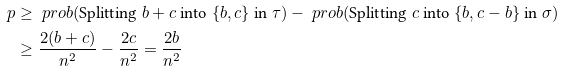<formula> <loc_0><loc_0><loc_500><loc_500>p & \geq \ p r o b ( \text {Splitting $b+c$ into $\{b, c\}$ in $\tau$} ) - \ p r o b ( \text {Splitting $c$ into $\{b, c-b\}$ in $\sigma$} ) \\ & \geq \frac { 2 ( b + c ) } { n ^ { 2 } } - \frac { 2 c } { n ^ { 2 } } = \frac { 2 b } { n ^ { 2 } }</formula> 